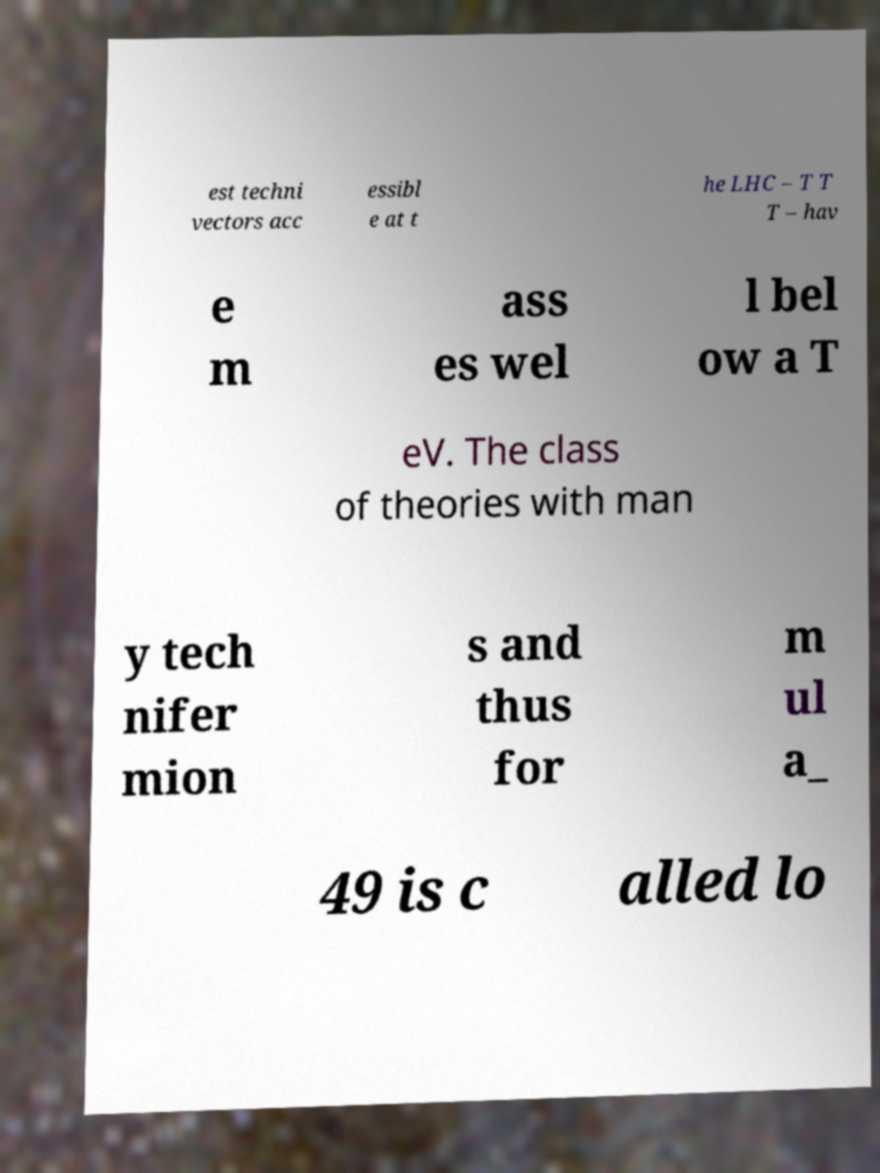Could you assist in decoding the text presented in this image and type it out clearly? est techni vectors acc essibl e at t he LHC – T T T – hav e m ass es wel l bel ow a T eV. The class of theories with man y tech nifer mion s and thus for m ul a_ 49 is c alled lo 